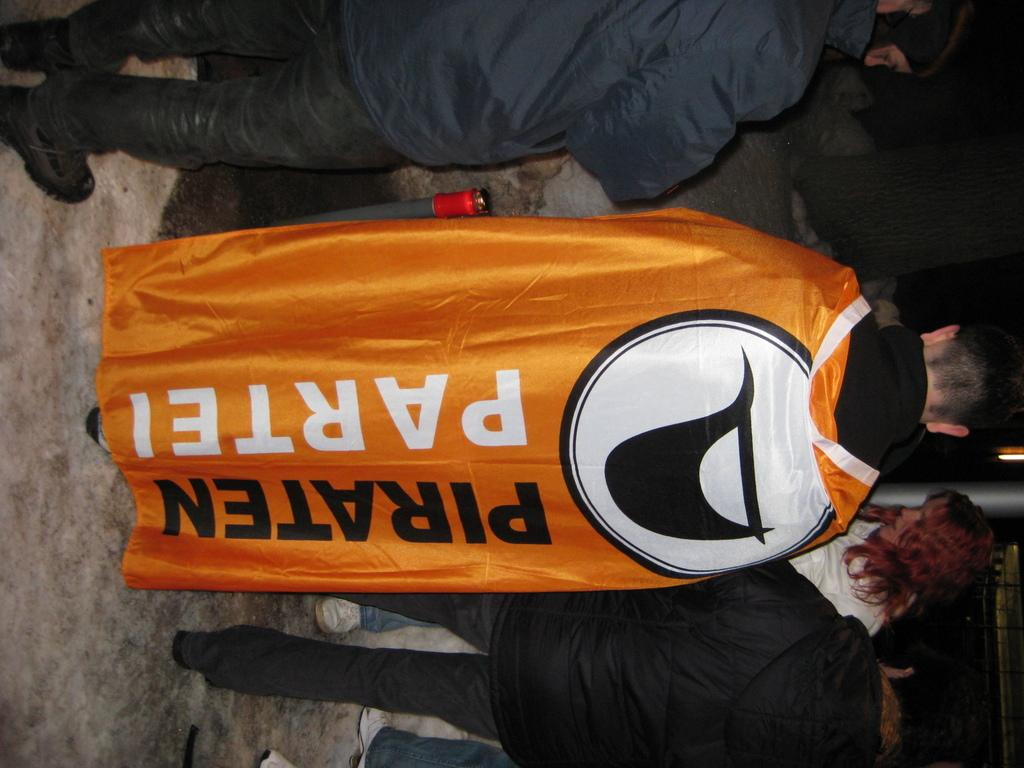<image>
Give a short and clear explanation of the subsequent image. A man is wearing a cape from the Piraten Partei (Pirate Party). 